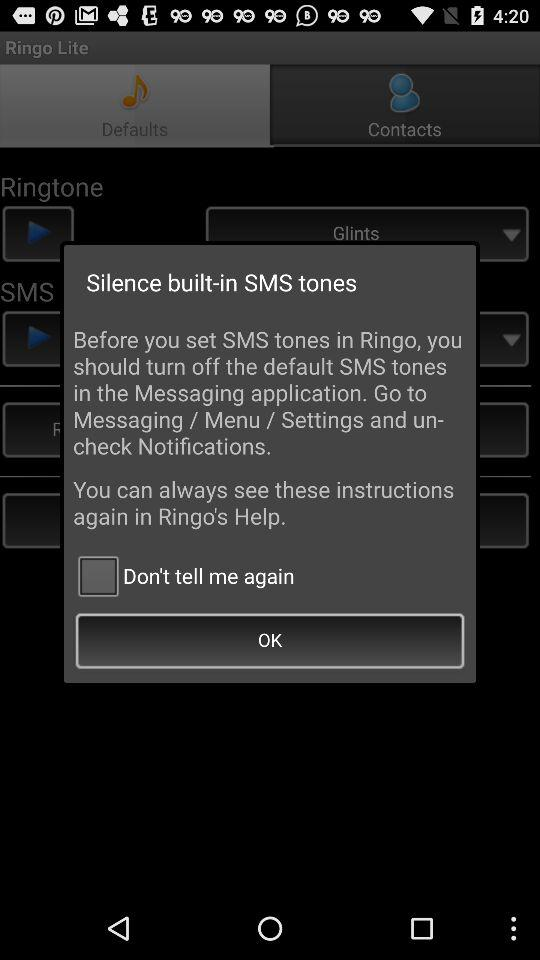What should we turn off before setting SMS tones in "Ringo"? You should turn off the default SMS tones. 